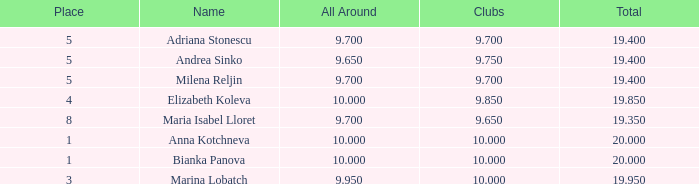What is the highest total that has andrea sinko as the name, with an all around greater than 9.65? None. 